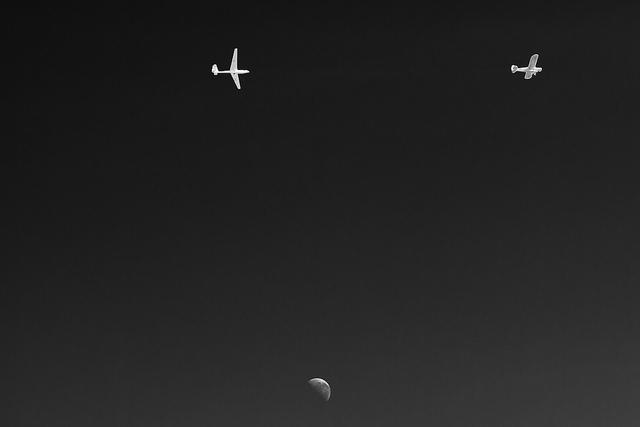Which color is dominant?
Be succinct. Black. What is this a picture of?
Answer briefly. Planes. What is in the sky?
Concise answer only. Planes. What time is it?
Answer briefly. Night. Are all jets in this photo facing the same direction?
Concise answer only. Yes. What time of day was the photo taken?
Keep it brief. Night. Is there a computer in this photo?
Answer briefly. No. What color is the bird?
Answer briefly. White. What color is the sky?
Be succinct. Black. How is the weather?
Concise answer only. Clear. What color is the background?
Give a very brief answer. Black. How many airplanes are there?
Give a very brief answer. 2. Do these three, small objects, against the black setting, resemble a minimalist cartoon face?
Keep it brief. Yes. What are the two bright objects?
Keep it brief. Planes. What are the big floating objects in the sky?
Give a very brief answer. Planes. 